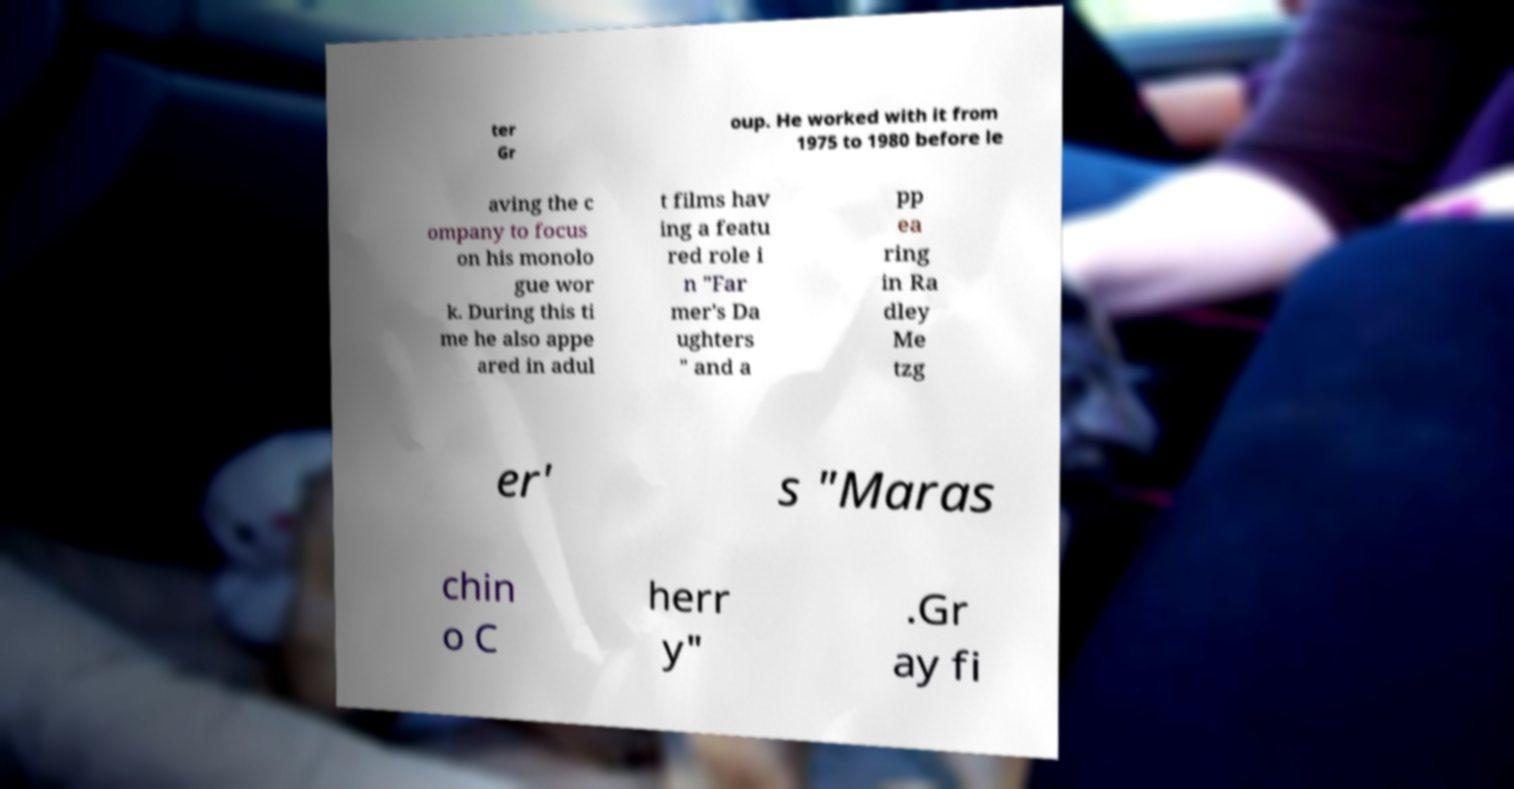For documentation purposes, I need the text within this image transcribed. Could you provide that? ter Gr oup. He worked with it from 1975 to 1980 before le aving the c ompany to focus on his monolo gue wor k. During this ti me he also appe ared in adul t films hav ing a featu red role i n "Far mer's Da ughters " and a pp ea ring in Ra dley Me tzg er' s "Maras chin o C herr y" .Gr ay fi 